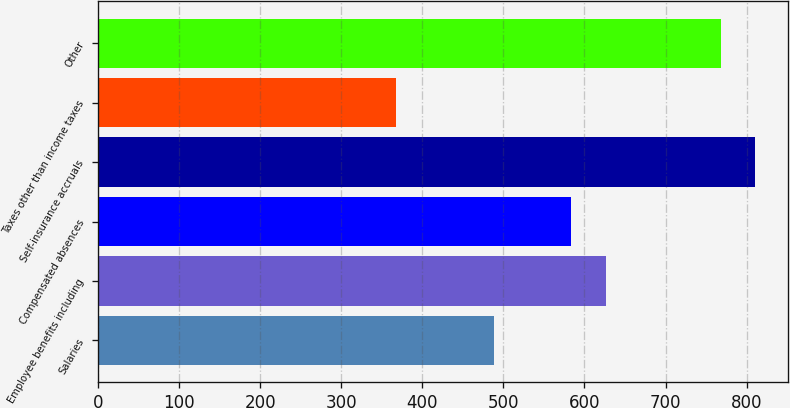Convert chart. <chart><loc_0><loc_0><loc_500><loc_500><bar_chart><fcel>Salaries<fcel>Employee benefits including<fcel>Compensated absences<fcel>Self-insurance accruals<fcel>Taxes other than income taxes<fcel>Other<nl><fcel>489<fcel>626.8<fcel>584<fcel>810.8<fcel>368<fcel>768<nl></chart> 